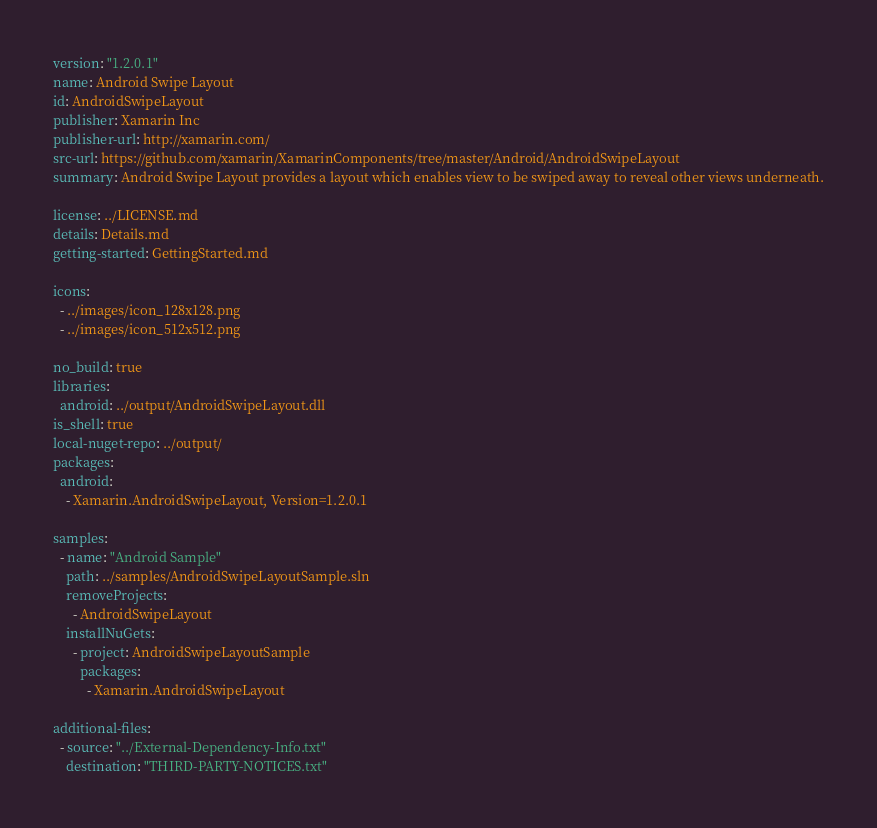Convert code to text. <code><loc_0><loc_0><loc_500><loc_500><_YAML_>version: "1.2.0.1"
name: Android Swipe Layout
id: AndroidSwipeLayout
publisher: Xamarin Inc
publisher-url: http://xamarin.com/
src-url: https://github.com/xamarin/XamarinComponents/tree/master/Android/AndroidSwipeLayout
summary: Android Swipe Layout provides a layout which enables view to be swiped away to reveal other views underneath.

license: ../LICENSE.md
details: Details.md
getting-started: GettingStarted.md

icons:
  - ../images/icon_128x128.png
  - ../images/icon_512x512.png

no_build: true
libraries:
  android: ../output/AndroidSwipeLayout.dll
is_shell: true
local-nuget-repo: ../output/
packages:
  android: 
    - Xamarin.AndroidSwipeLayout, Version=1.2.0.1

samples:
  - name: "Android Sample"
    path: ../samples/AndroidSwipeLayoutSample.sln
    removeProjects:
      - AndroidSwipeLayout
    installNuGets:
      - project: AndroidSwipeLayoutSample
        packages:
          - Xamarin.AndroidSwipeLayout

additional-files:
  - source: "../External-Dependency-Info.txt"
    destination: "THIRD-PARTY-NOTICES.txt"
</code> 